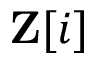<formula> <loc_0><loc_0><loc_500><loc_500>Z [ i ]</formula> 